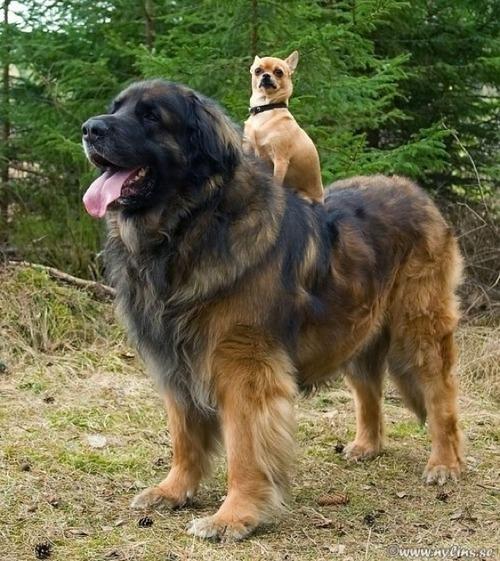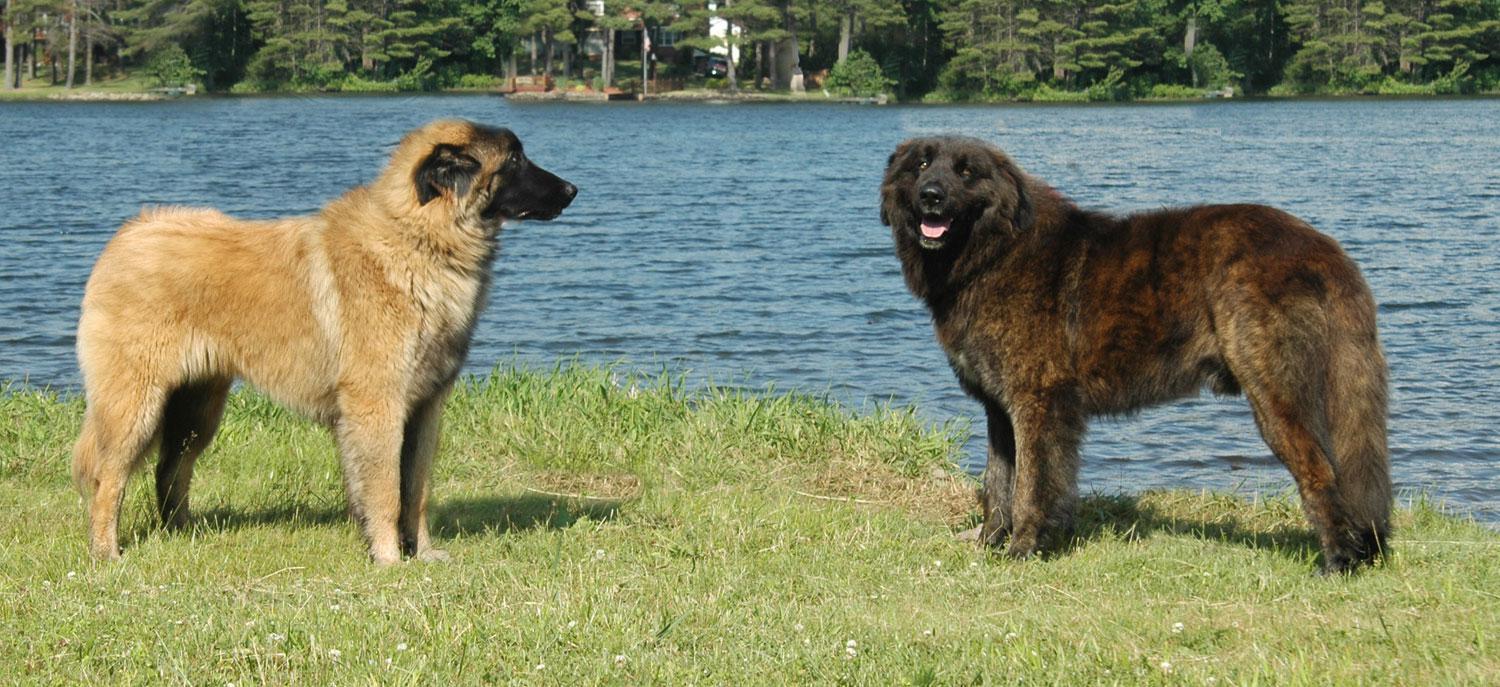The first image is the image on the left, the second image is the image on the right. Assess this claim about the two images: "Right and left images contain the same number of dogs.". Correct or not? Answer yes or no. Yes. The first image is the image on the left, the second image is the image on the right. For the images displayed, is the sentence "There are no more than three dogs" factually correct? Answer yes or no. No. 